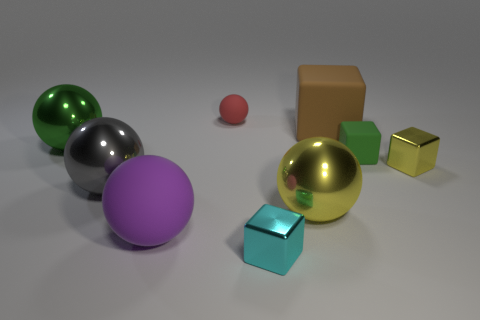Subtract all green balls. How many balls are left? 4 Subtract all tiny red matte balls. How many balls are left? 4 Subtract all brown spheres. Subtract all yellow cylinders. How many spheres are left? 5 Add 1 green metallic things. How many objects exist? 10 Subtract all balls. How many objects are left? 4 Subtract 0 purple cylinders. How many objects are left? 9 Subtract all gray matte cylinders. Subtract all big matte things. How many objects are left? 7 Add 1 cyan metallic blocks. How many cyan metallic blocks are left? 2 Add 9 big cyan matte objects. How many big cyan matte objects exist? 9 